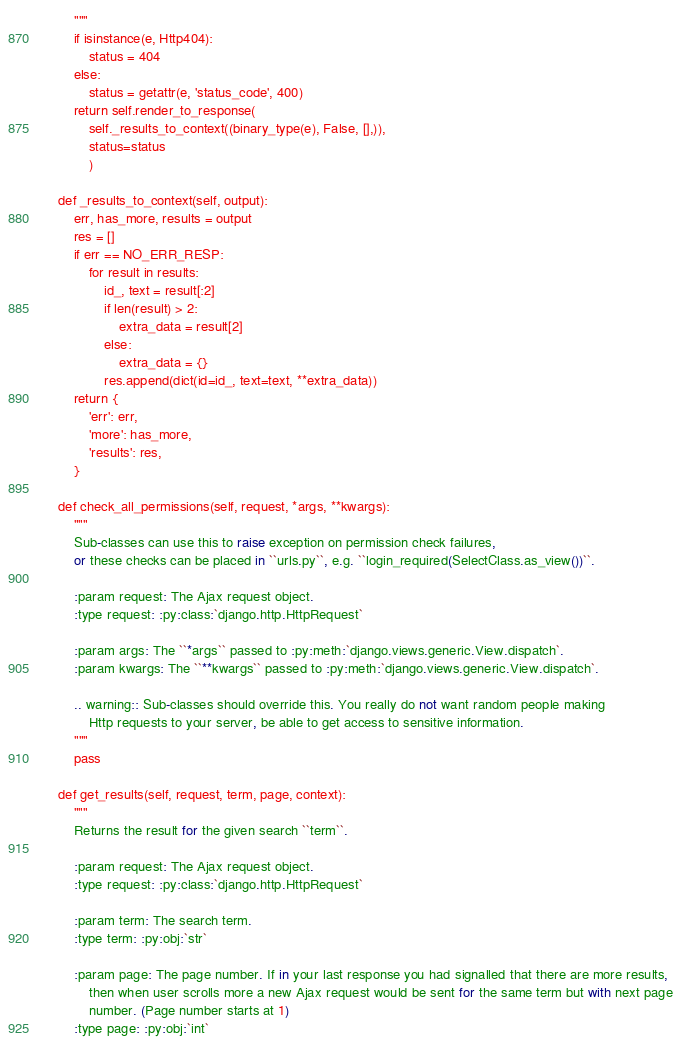<code> <loc_0><loc_0><loc_500><loc_500><_Python_>        """
        if isinstance(e, Http404):
            status = 404
        else:
            status = getattr(e, 'status_code', 400)
        return self.render_to_response(
            self._results_to_context((binary_type(e), False, [],)),
            status=status
            )

    def _results_to_context(self, output):
        err, has_more, results = output
        res = []
        if err == NO_ERR_RESP:
            for result in results:
                id_, text = result[:2]
                if len(result) > 2:
                    extra_data = result[2]
                else:
                    extra_data = {}
                res.append(dict(id=id_, text=text, **extra_data))
        return {
            'err': err,
            'more': has_more,
            'results': res,
        }

    def check_all_permissions(self, request, *args, **kwargs):
        """
        Sub-classes can use this to raise exception on permission check failures,
        or these checks can be placed in ``urls.py``, e.g. ``login_required(SelectClass.as_view())``.

        :param request: The Ajax request object.
        :type request: :py:class:`django.http.HttpRequest`

        :param args: The ``*args`` passed to :py:meth:`django.views.generic.View.dispatch`.
        :param kwargs: The ``**kwargs`` passed to :py:meth:`django.views.generic.View.dispatch`.

        .. warning:: Sub-classes should override this. You really do not want random people making
            Http requests to your server, be able to get access to sensitive information.
        """
        pass

    def get_results(self, request, term, page, context):
        """
        Returns the result for the given search ``term``.

        :param request: The Ajax request object.
        :type request: :py:class:`django.http.HttpRequest`

        :param term: The search term.
        :type term: :py:obj:`str`

        :param page: The page number. If in your last response you had signalled that there are more results,
            then when user scrolls more a new Ajax request would be sent for the same term but with next page
            number. (Page number starts at 1)
        :type page: :py:obj:`int`
</code> 